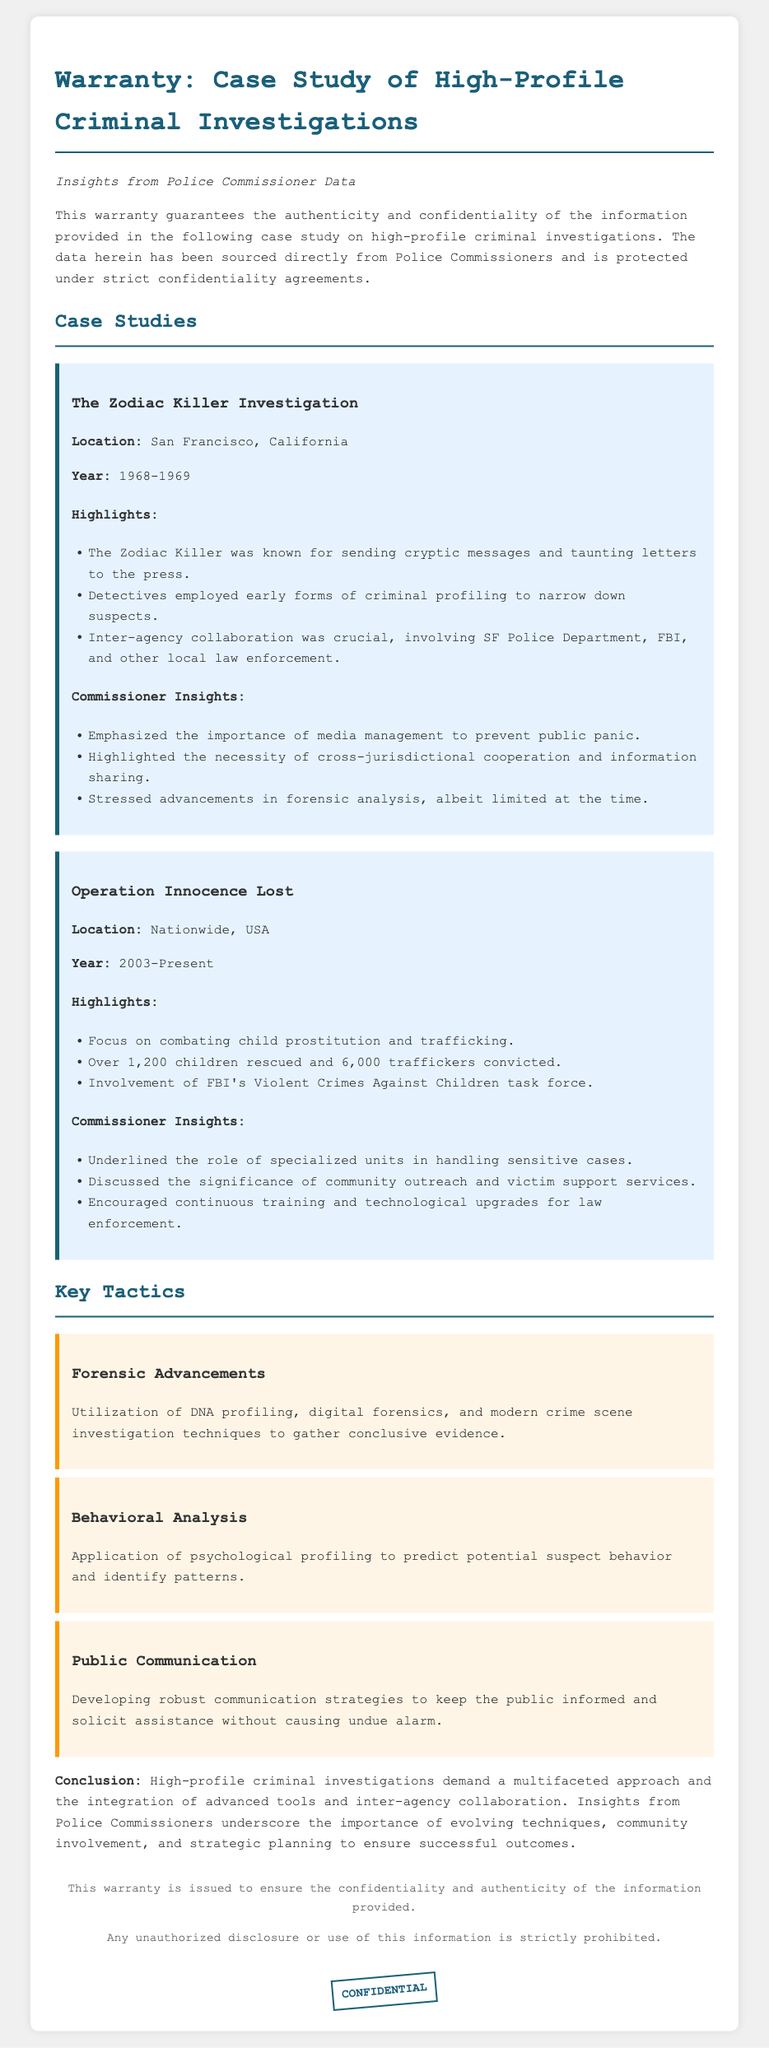What was the location for the Zodiac Killer investigation? The location is specified in the document under the case study section for the Zodiac Killer investigation.
Answer: San Francisco, California What year did Operation Innocence Lost start? The year is mentioned in the document detailing the timeline of Operation Innocence Lost.
Answer: 2003 How many children were rescued in Operation Innocence Lost? The number of children rescued is listed in the highlights of the Operation Innocence Lost case study.
Answer: 1,200 What is one key tactic mentioned in the document? The document lists various tactics in the Key Tactics section; choosing one from there meets the requirement.
Answer: Forensic Advancements What does the Police Commissioner emphasize about media management? The emphasis on media management is noted in the Commissioner Insights from the Zodiac Killer investigation case study.
Answer: Importance of media management to prevent public panic What tactic focuses on the prediction of suspect behavior? The tactic focused on predicting behavior is detailed in the Key Tactics section, requiring integration of information from the document.
Answer: Behavioral Analysis What keyword indicates the document's confidentiality? The document includes a specific keyword near the end, emphasizing the document's confidentiality.
Answer: CONFIDENTIAL 